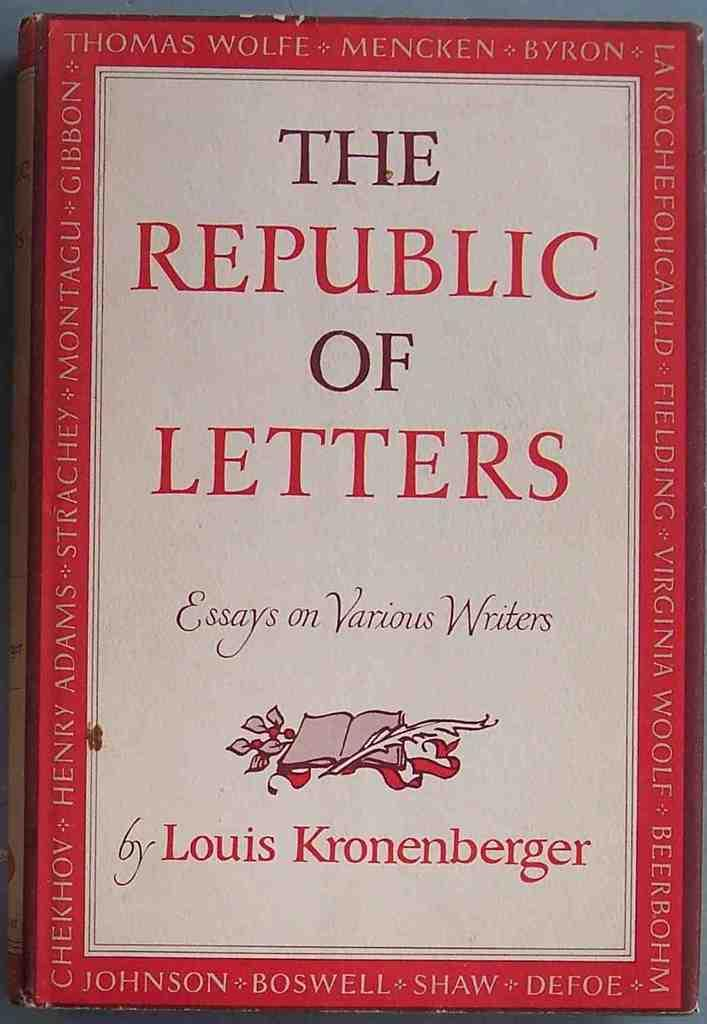<image>
Give a short and clear explanation of the subsequent image. A book of essays was compiled by Louis Kronenberg. 